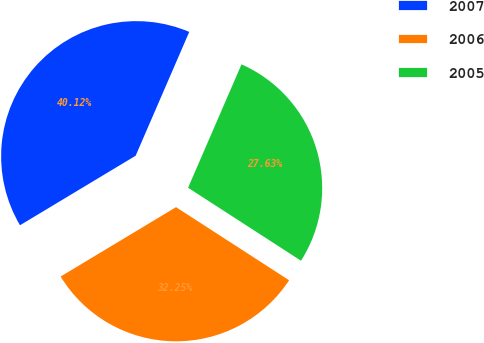Convert chart. <chart><loc_0><loc_0><loc_500><loc_500><pie_chart><fcel>2007<fcel>2006<fcel>2005<nl><fcel>40.12%<fcel>32.25%<fcel>27.63%<nl></chart> 